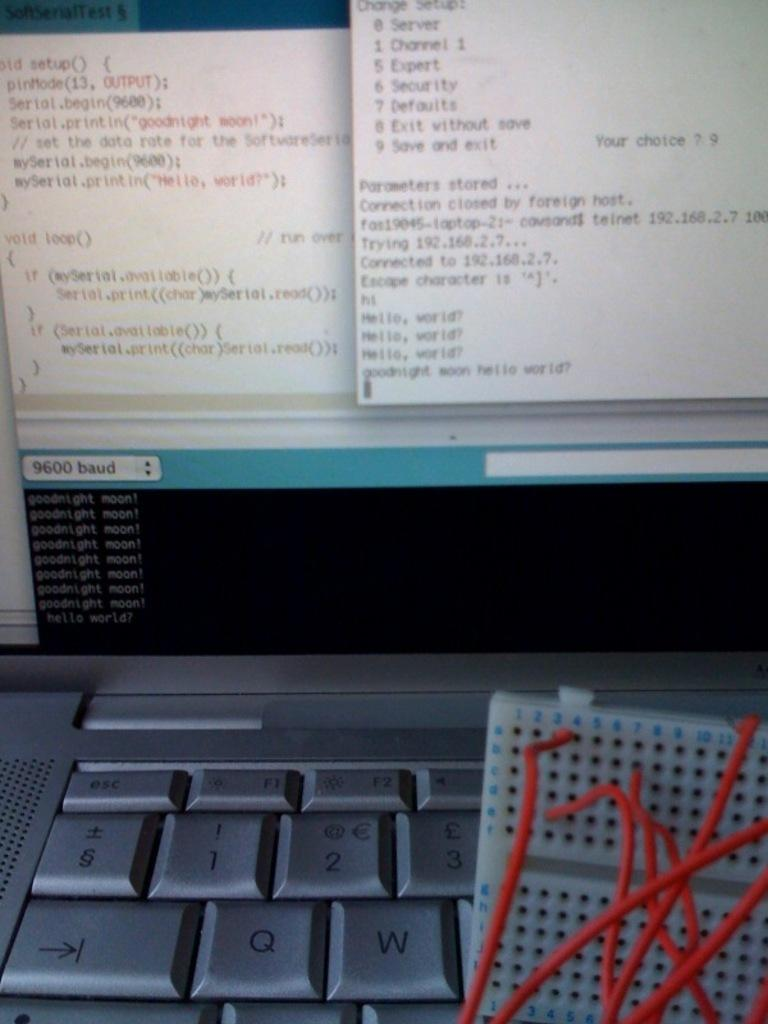<image>
Present a compact description of the photo's key features. The Q and W key are visible on the keyboard. 